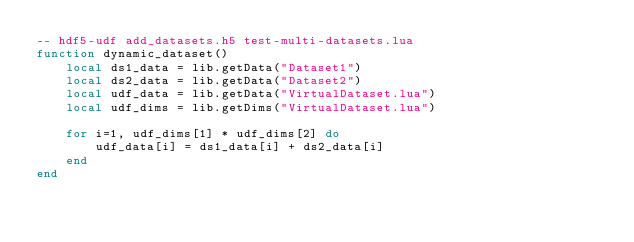<code> <loc_0><loc_0><loc_500><loc_500><_Lua_>-- hdf5-udf add_datasets.h5 test-multi-datasets.lua
function dynamic_dataset()
    local ds1_data = lib.getData("Dataset1")
    local ds2_data = lib.getData("Dataset2")
    local udf_data = lib.getData("VirtualDataset.lua")
    local udf_dims = lib.getDims("VirtualDataset.lua")

    for i=1, udf_dims[1] * udf_dims[2] do
        udf_data[i] = ds1_data[i] + ds2_data[i]
    end
end</code> 